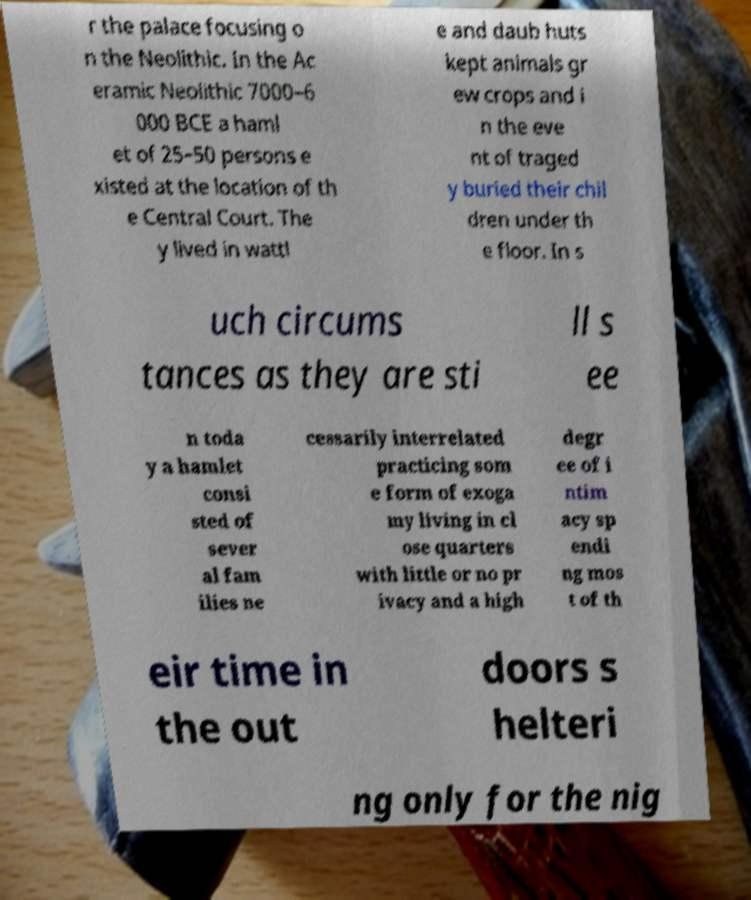Can you accurately transcribe the text from the provided image for me? r the palace focusing o n the Neolithic. In the Ac eramic Neolithic 7000–6 000 BCE a haml et of 25–50 persons e xisted at the location of th e Central Court. The y lived in wattl e and daub huts kept animals gr ew crops and i n the eve nt of traged y buried their chil dren under th e floor. In s uch circums tances as they are sti ll s ee n toda y a hamlet consi sted of sever al fam ilies ne cessarily interrelated practicing som e form of exoga my living in cl ose quarters with little or no pr ivacy and a high degr ee of i ntim acy sp endi ng mos t of th eir time in the out doors s helteri ng only for the nig 